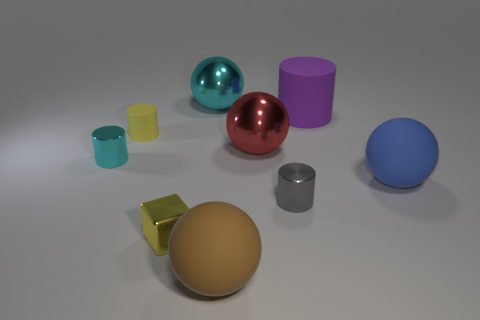There is a matte object to the left of the large brown matte sphere; is its color the same as the big cylinder?
Keep it short and to the point. No. There is a blue rubber ball; are there any small cubes to the left of it?
Provide a succinct answer. Yes. There is a object that is in front of the red thing and behind the big blue matte object; what color is it?
Your answer should be very brief. Cyan. There is a small rubber thing that is the same color as the cube; what shape is it?
Your answer should be very brief. Cylinder. There is a matte cylinder that is on the right side of the matte thing left of the brown matte ball; what size is it?
Offer a very short reply. Large. How many balls are either brown things or large purple rubber objects?
Give a very brief answer. 1. The matte sphere that is the same size as the blue thing is what color?
Your answer should be compact. Brown. What shape is the metal thing behind the rubber cylinder that is on the left side of the red sphere?
Your answer should be very brief. Sphere. There is a cyan metal thing that is to the left of the yellow metal thing; is it the same size as the brown object?
Offer a very short reply. No. What number of other objects are the same material as the big red thing?
Offer a terse response. 4. 